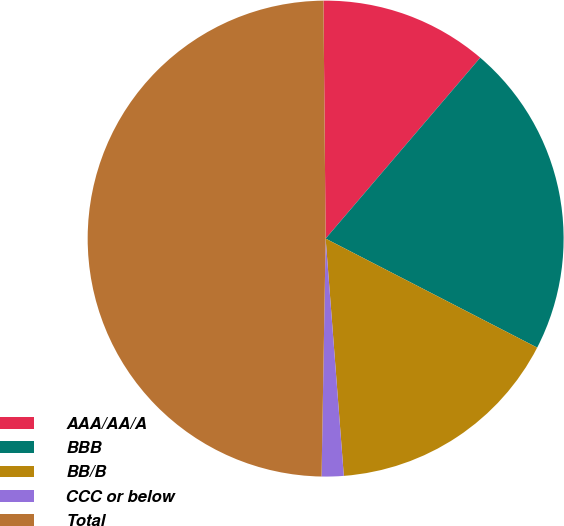<chart> <loc_0><loc_0><loc_500><loc_500><pie_chart><fcel>AAA/AA/A<fcel>BBB<fcel>BB/B<fcel>CCC or below<fcel>Total<nl><fcel>11.4%<fcel>21.32%<fcel>16.21%<fcel>1.49%<fcel>49.58%<nl></chart> 